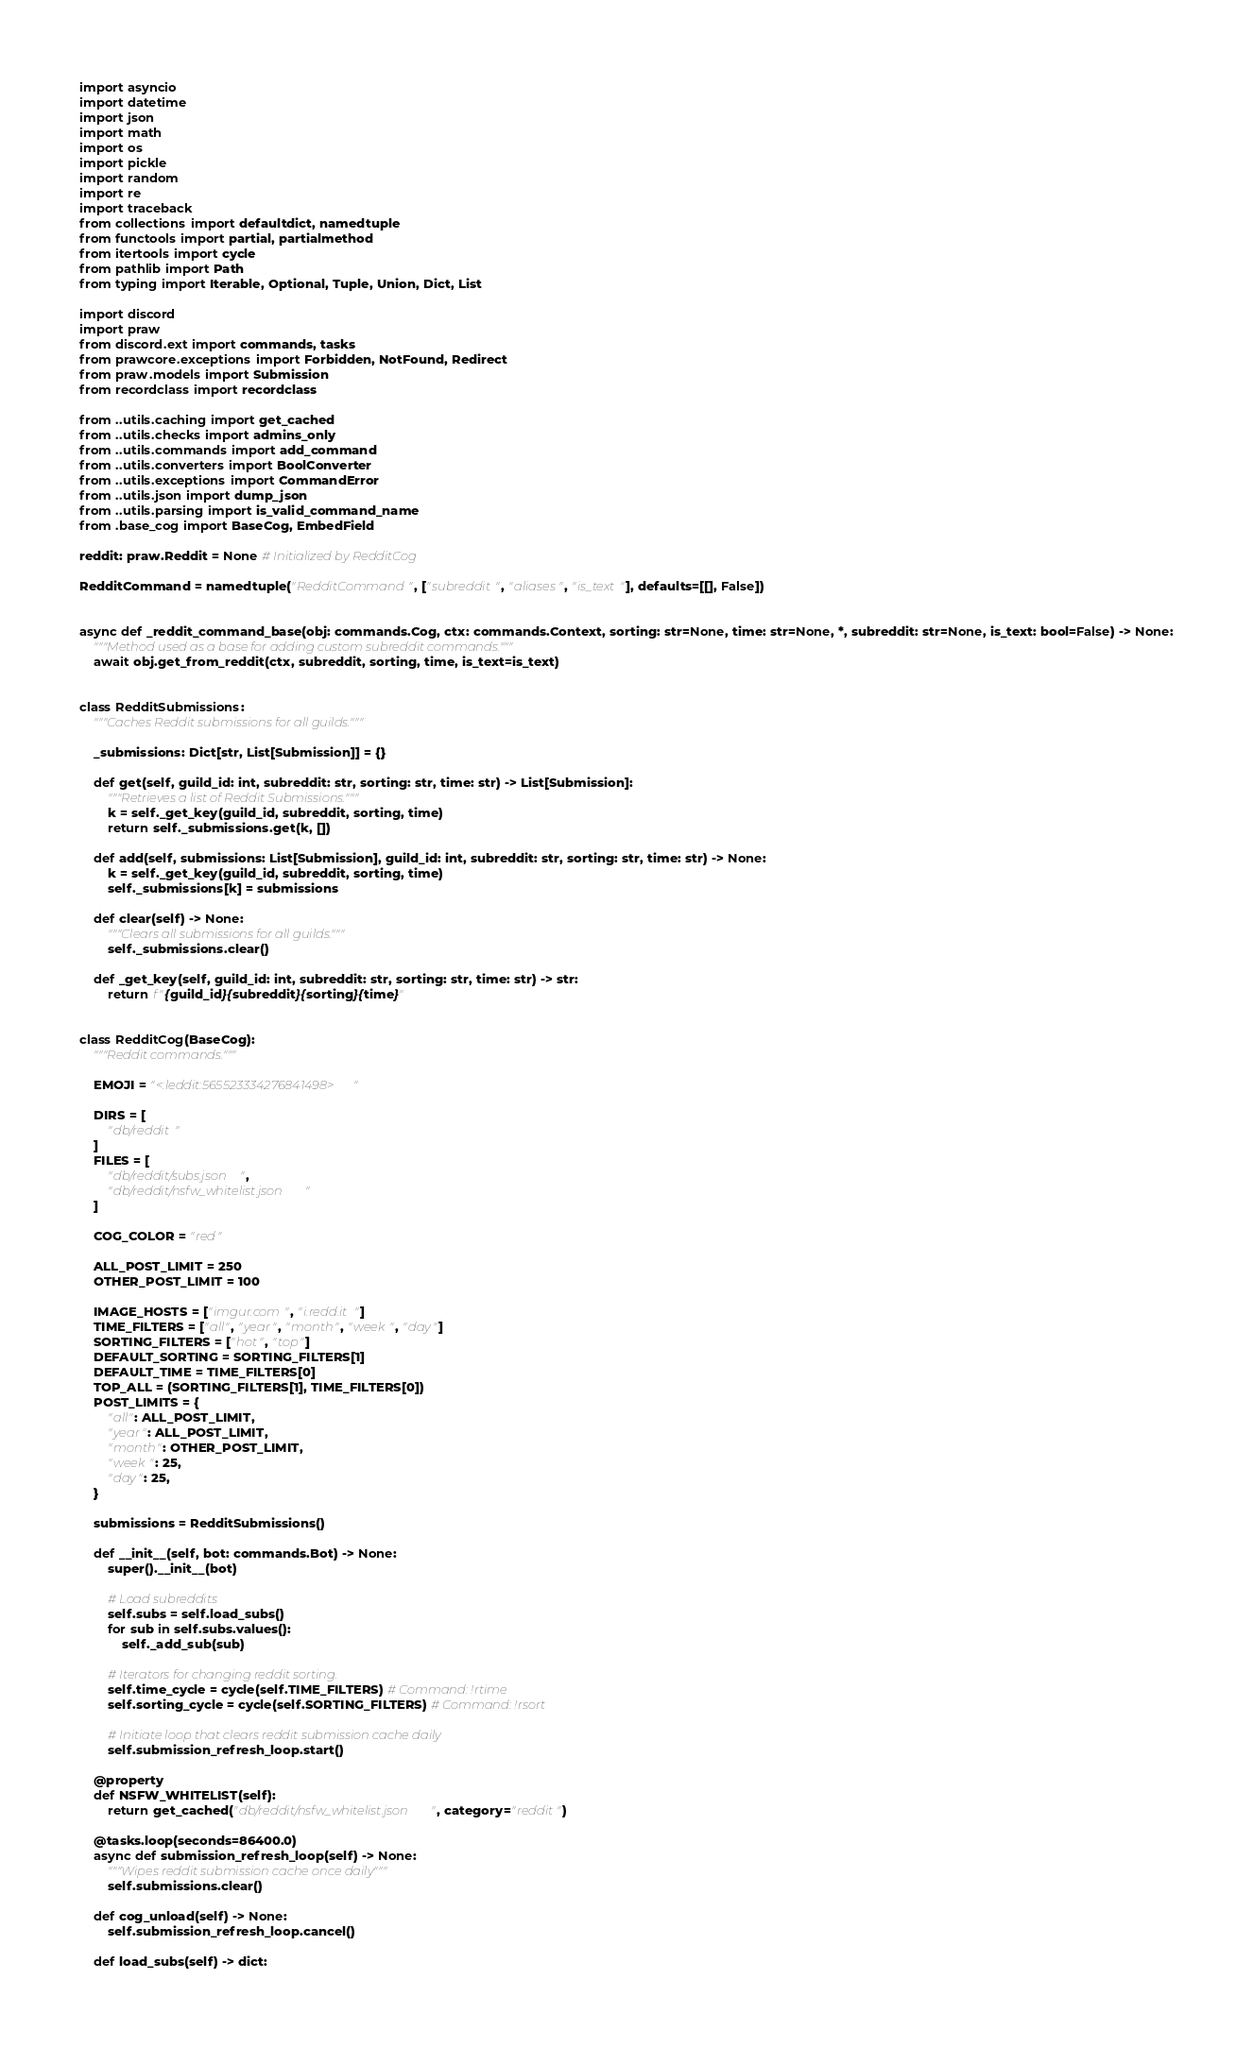Convert code to text. <code><loc_0><loc_0><loc_500><loc_500><_Python_>import asyncio
import datetime
import json
import math
import os
import pickle
import random
import re
import traceback
from collections import defaultdict, namedtuple
from functools import partial, partialmethod
from itertools import cycle
from pathlib import Path
from typing import Iterable, Optional, Tuple, Union, Dict, List

import discord
import praw
from discord.ext import commands, tasks
from prawcore.exceptions import Forbidden, NotFound, Redirect
from praw.models import Submission
from recordclass import recordclass

from ..utils.caching import get_cached
from ..utils.checks import admins_only
from ..utils.commands import add_command
from ..utils.converters import BoolConverter
from ..utils.exceptions import CommandError
from ..utils.json import dump_json
from ..utils.parsing import is_valid_command_name
from .base_cog import BaseCog, EmbedField

reddit: praw.Reddit = None # Initialized by RedditCog

RedditCommand = namedtuple("RedditCommand", ["subreddit", "aliases", "is_text"], defaults=[[], False])


async def _reddit_command_base(obj: commands.Cog, ctx: commands.Context, sorting: str=None, time: str=None, *, subreddit: str=None, is_text: bool=False) -> None:
    """Method used as a base for adding custom subreddit commands."""
    await obj.get_from_reddit(ctx, subreddit, sorting, time, is_text=is_text)


class RedditSubmissions:
    """Caches Reddit submissions for all guilds."""

    _submissions: Dict[str, List[Submission]] = {}

    def get(self, guild_id: int, subreddit: str, sorting: str, time: str) -> List[Submission]:
        """Retrieves a list of Reddit Submissions."""
        k = self._get_key(guild_id, subreddit, sorting, time)
        return self._submissions.get(k, [])

    def add(self, submissions: List[Submission], guild_id: int, subreddit: str, sorting: str, time: str) -> None:
        k = self._get_key(guild_id, subreddit, sorting, time)
        self._submissions[k] = submissions

    def clear(self) -> None:
        """Clears all submissions for all guilds."""
        self._submissions.clear()

    def _get_key(self, guild_id: int, subreddit: str, sorting: str, time: str) -> str:
        return f"{guild_id}{subreddit}{sorting}{time}"


class RedditCog(BaseCog):
    """Reddit commands."""

    EMOJI = "<:leddit:565523334276841498>"
    
    DIRS = [
        "db/reddit"
    ]
    FILES = [
        "db/reddit/subs.json",
        "db/reddit/nsfw_whitelist.json"
    ]

    COG_COLOR = "red"

    ALL_POST_LIMIT = 250
    OTHER_POST_LIMIT = 100
    
    IMAGE_HOSTS = ["imgur.com", "i.redd.it"]
    TIME_FILTERS = ["all", "year", "month", "week", "day"]
    SORTING_FILTERS = ["hot", "top"]
    DEFAULT_SORTING = SORTING_FILTERS[1]
    DEFAULT_TIME = TIME_FILTERS[0]
    TOP_ALL = (SORTING_FILTERS[1], TIME_FILTERS[0])
    POST_LIMITS = {
        "all": ALL_POST_LIMIT,
        "year": ALL_POST_LIMIT,
        "month": OTHER_POST_LIMIT,
        "week": 25,
        "day": 25,
    }

    submissions = RedditSubmissions()

    def __init__(self, bot: commands.Bot) -> None:
        super().__init__(bot)

        # Load subreddits
        self.subs = self.load_subs()
        for sub in self.subs.values():
            self._add_sub(sub)
        
        # Iterators for changing reddit sorting.
        self.time_cycle = cycle(self.TIME_FILTERS) # Command: !rtime
        self.sorting_cycle = cycle(self.SORTING_FILTERS) # Command: !rsort
        
        # Initiate loop that clears reddit submission cache daily
        self.submission_refresh_loop.start()
    
    @property
    def NSFW_WHITELIST(self):
        return get_cached("db/reddit/nsfw_whitelist.json", category="reddit")
    
    @tasks.loop(seconds=86400.0)
    async def submission_refresh_loop(self) -> None:
        """Wipes reddit submission cache once daily"""
        self.submissions.clear()    
    
    def cog_unload(self) -> None:
        self.submission_refresh_loop.cancel()        

    def load_subs(self) -> dict:</code> 